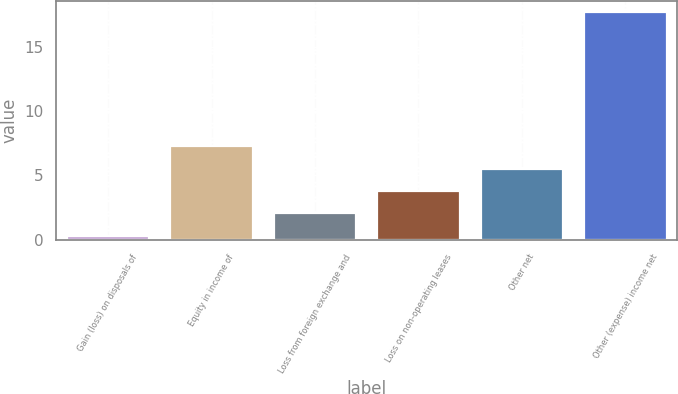Convert chart to OTSL. <chart><loc_0><loc_0><loc_500><loc_500><bar_chart><fcel>Gain (loss) on disposals of<fcel>Equity in income of<fcel>Loss from foreign exchange and<fcel>Loss on non-operating leases<fcel>Other net<fcel>Other (expense) income net<nl><fcel>0.3<fcel>7.26<fcel>2.04<fcel>3.78<fcel>5.52<fcel>17.7<nl></chart> 